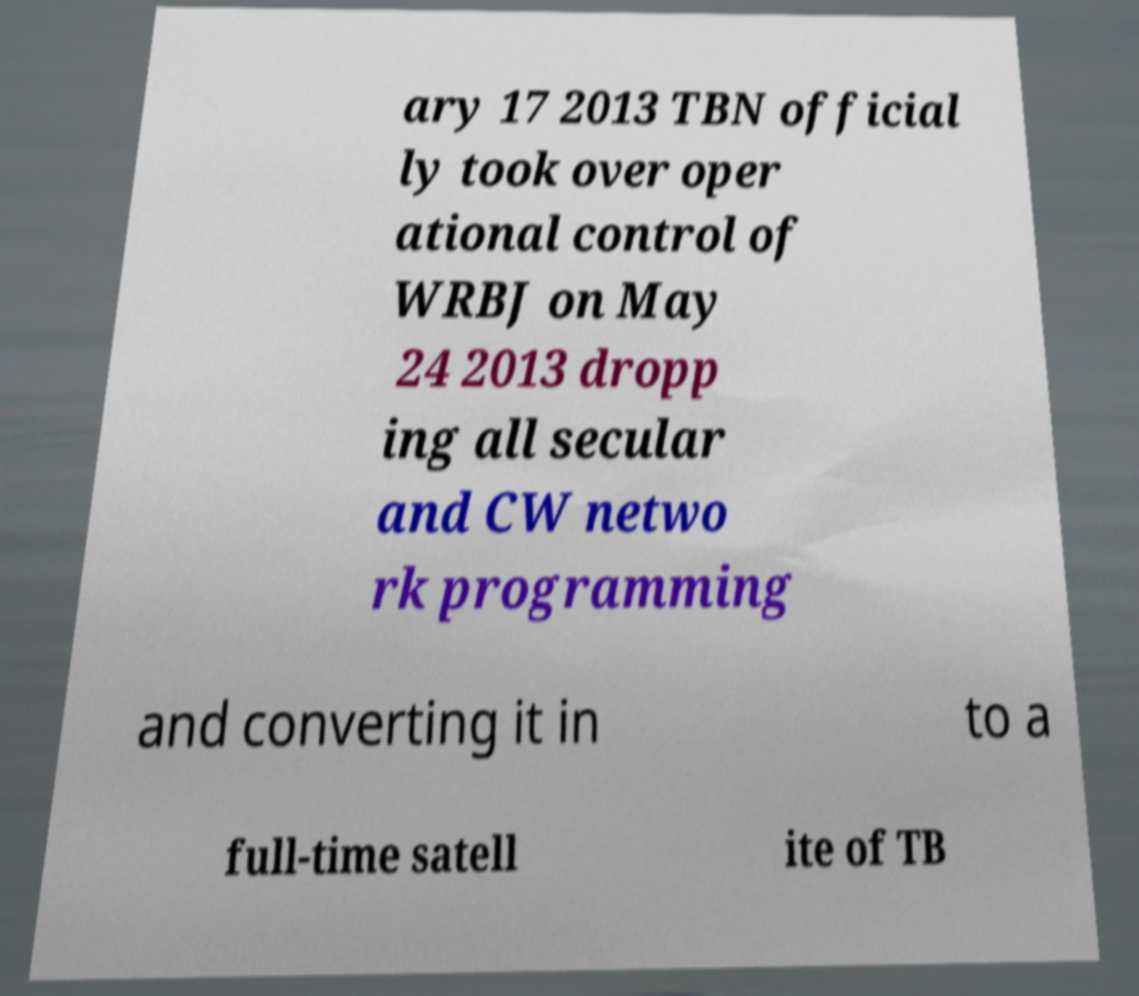Please identify and transcribe the text found in this image. ary 17 2013 TBN official ly took over oper ational control of WRBJ on May 24 2013 dropp ing all secular and CW netwo rk programming and converting it in to a full-time satell ite of TB 